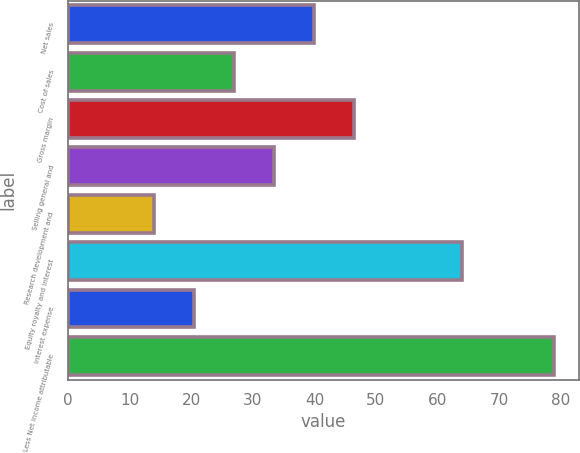<chart> <loc_0><loc_0><loc_500><loc_500><bar_chart><fcel>Net sales<fcel>Cost of sales<fcel>Gross margin<fcel>Selling general and<fcel>Research development and<fcel>Equity royalty and interest<fcel>Interest expense<fcel>Less Net income attributable<nl><fcel>40<fcel>27<fcel>46.5<fcel>33.5<fcel>14<fcel>64<fcel>20.5<fcel>79<nl></chart> 